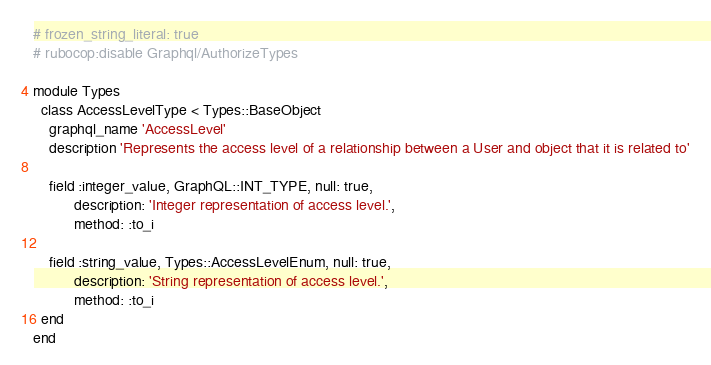Convert code to text. <code><loc_0><loc_0><loc_500><loc_500><_Ruby_># frozen_string_literal: true
# rubocop:disable Graphql/AuthorizeTypes

module Types
  class AccessLevelType < Types::BaseObject
    graphql_name 'AccessLevel'
    description 'Represents the access level of a relationship between a User and object that it is related to'

    field :integer_value, GraphQL::INT_TYPE, null: true,
          description: 'Integer representation of access level.',
          method: :to_i

    field :string_value, Types::AccessLevelEnum, null: true,
          description: 'String representation of access level.',
          method: :to_i
  end
end
</code> 